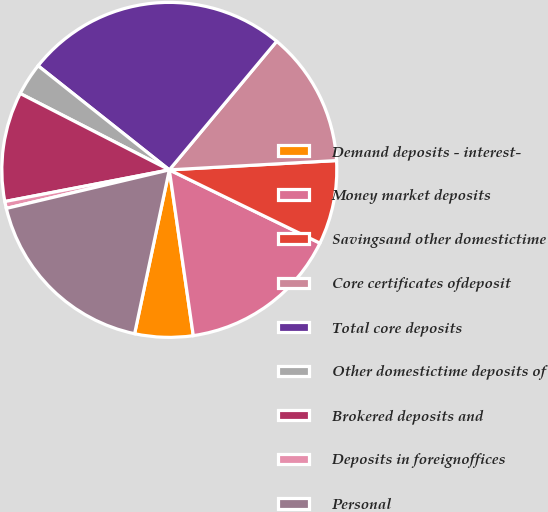Convert chart to OTSL. <chart><loc_0><loc_0><loc_500><loc_500><pie_chart><fcel>Demand deposits - interest-<fcel>Money market deposits<fcel>Savingsand other domestictime<fcel>Core certificates ofdeposit<fcel>Total core deposits<fcel>Other domestictime deposits of<fcel>Brokered deposits and<fcel>Deposits in foreignoffices<fcel>Personal<nl><fcel>5.61%<fcel>15.51%<fcel>8.09%<fcel>13.04%<fcel>25.4%<fcel>3.14%<fcel>10.56%<fcel>0.67%<fcel>17.98%<nl></chart> 